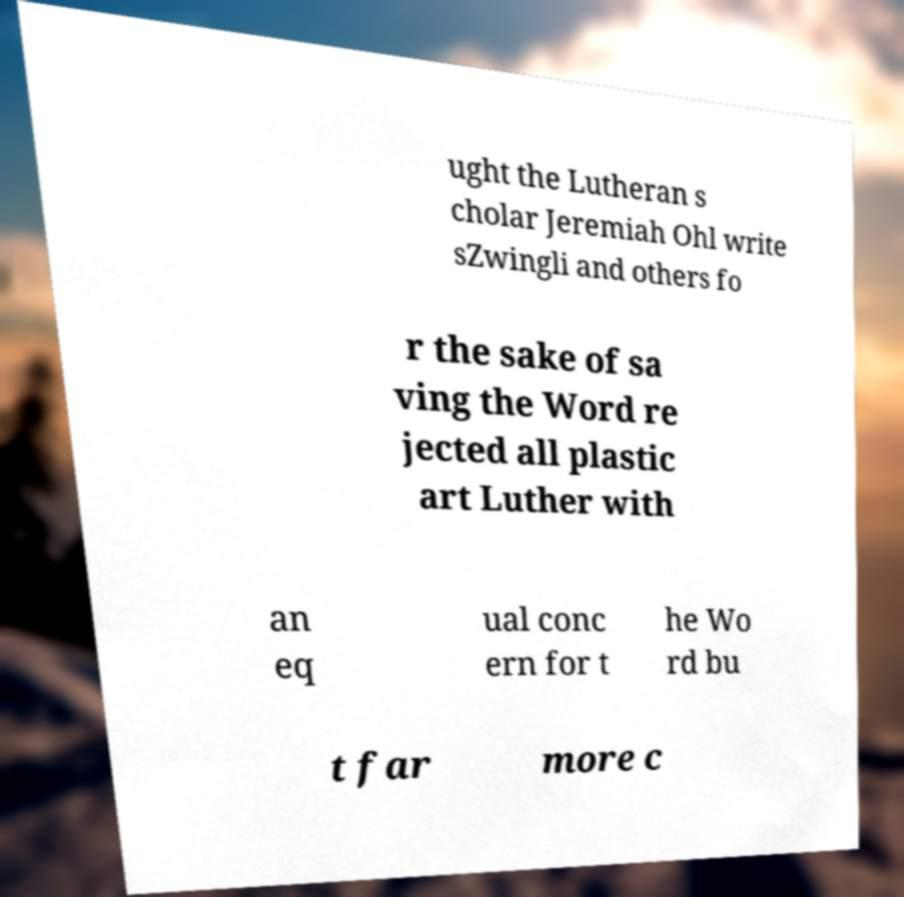What messages or text are displayed in this image? I need them in a readable, typed format. ught the Lutheran s cholar Jeremiah Ohl write sZwingli and others fo r the sake of sa ving the Word re jected all plastic art Luther with an eq ual conc ern for t he Wo rd bu t far more c 